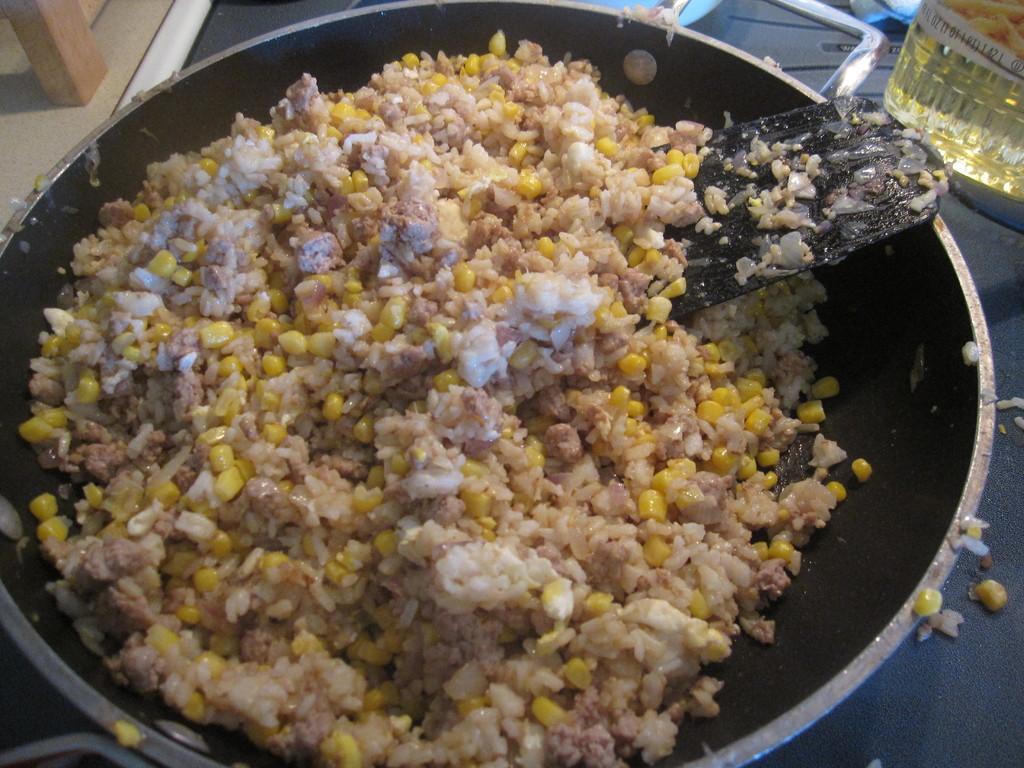How would you summarize this image in a sentence or two? In this image there is corn, rice and a pan stick inside a pan, beside the pan there is a bottle of oil. 